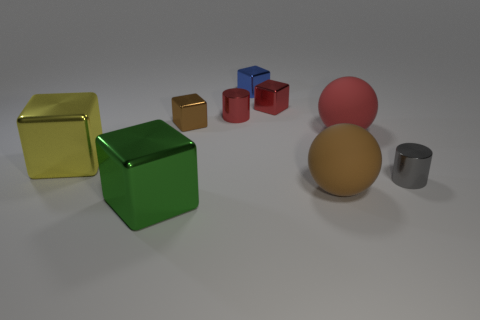There is a brown object that is in front of the tiny brown block that is behind the large thing left of the green metal object; what is its shape?
Keep it short and to the point. Sphere. Are there more tiny brown cubes that are on the left side of the red matte ball than tiny brown blocks in front of the yellow block?
Ensure brevity in your answer.  Yes. Are there any large green cubes right of the blue block?
Keep it short and to the point. No. There is a red thing that is both to the left of the brown matte object and to the right of the red cylinder; what is it made of?
Make the answer very short. Metal. What color is the other matte thing that is the same shape as the big red matte thing?
Give a very brief answer. Brown. There is a cylinder to the right of the blue cube; are there any brown rubber things behind it?
Offer a terse response. No. What is the size of the red sphere?
Your answer should be compact. Large. What is the shape of the small metal object that is both in front of the small red metallic cube and behind the brown block?
Provide a short and direct response. Cylinder. How many red objects are either blocks or matte things?
Make the answer very short. 2. Is the size of the metallic thing that is on the left side of the green metal cube the same as the red thing right of the brown sphere?
Provide a succinct answer. Yes. 